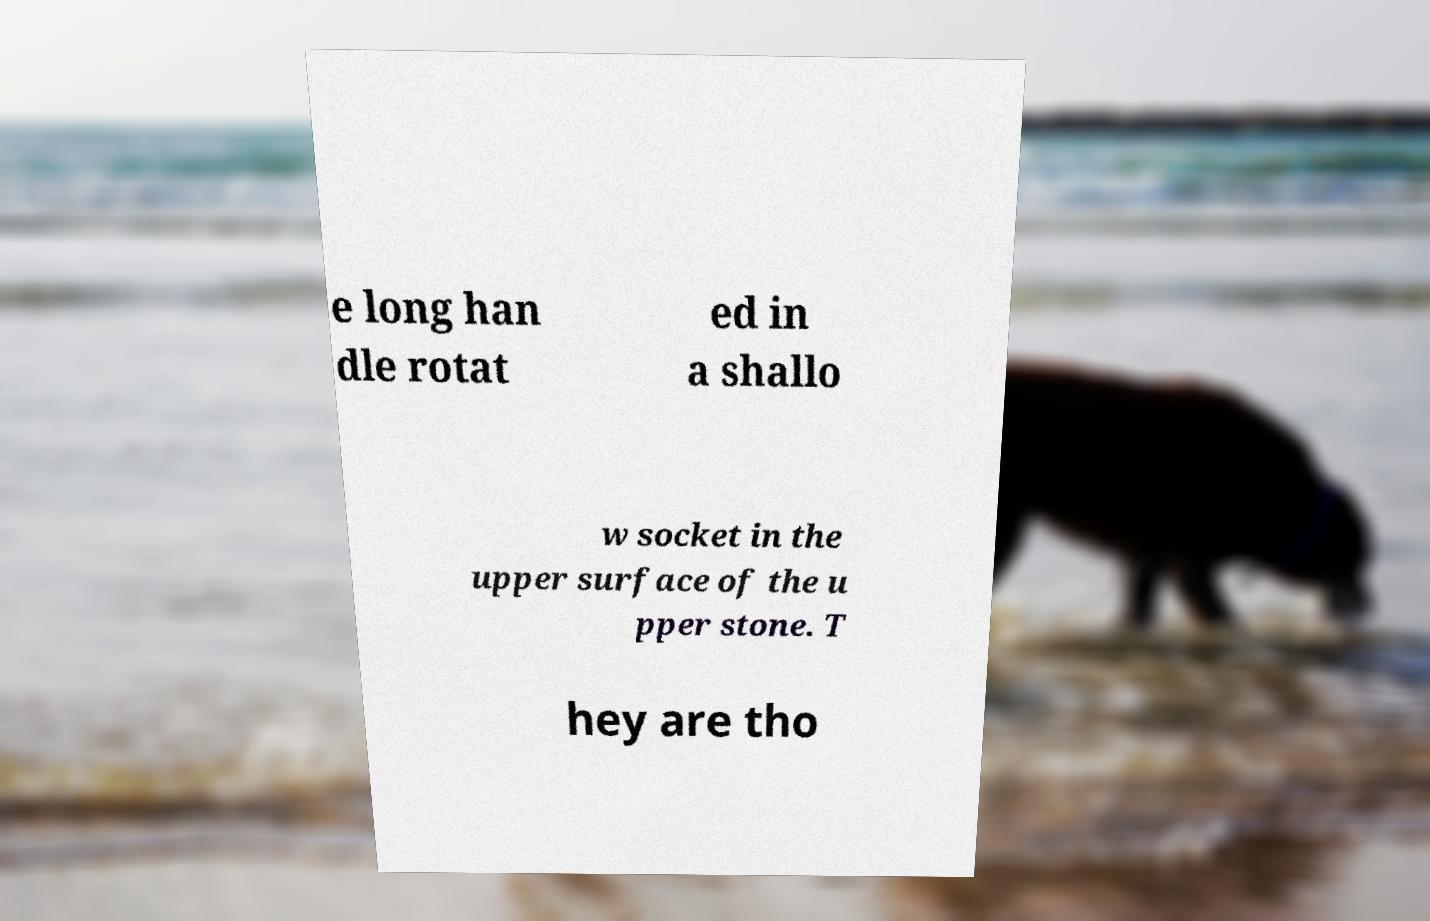Please identify and transcribe the text found in this image. e long han dle rotat ed in a shallo w socket in the upper surface of the u pper stone. T hey are tho 